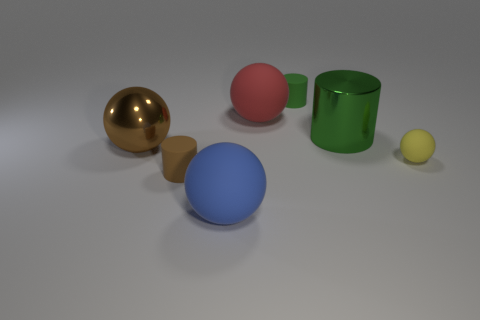Do the yellow ball and the big brown thing have the same material? The yellow ball appears to have a matte surface, likely made from a material like plastic or rubber, whereas the large brown object has a reflective metallic finish, indicating it is likely made of metal. So, the materials differ in both appearance and properties. 